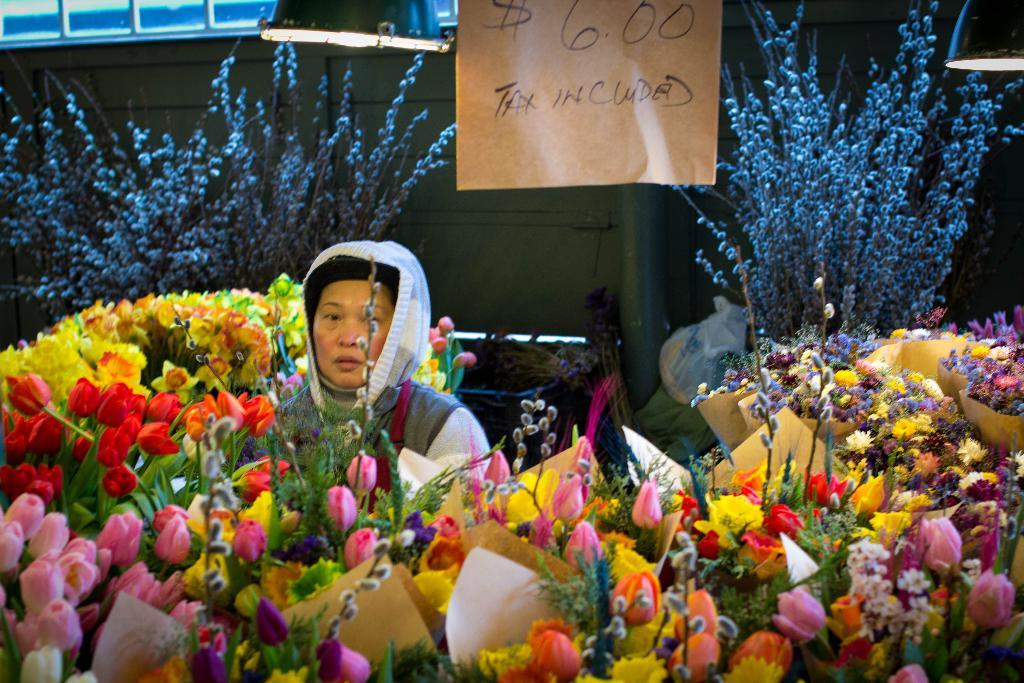What can be seen in the image that represents flowers? There are bouquets in the image. Who or what is present in the image along with the bouquets? There is a person in the image. What is a flat, solid surface that can be seen in the image? There is a board in the image. What can be seen in the image that provides illumination? There are lights in the image. What is a vertical surface that can be seen in the image? There is a wall in the image. What can be seen in the image that are not specifically mentioned in the facts? There are objects in the image. What is written or displayed on the board in the image? Something is written on the board. How many pieces of furniture can be seen in the image? There is no furniture present in the image. What type of step can be seen in the image? There is no step present in the image. 